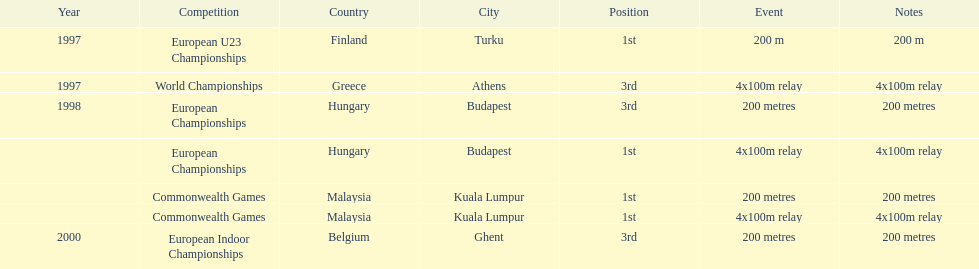How long was the sprint from the european indoor championships competition in 2000? 200 metres. 